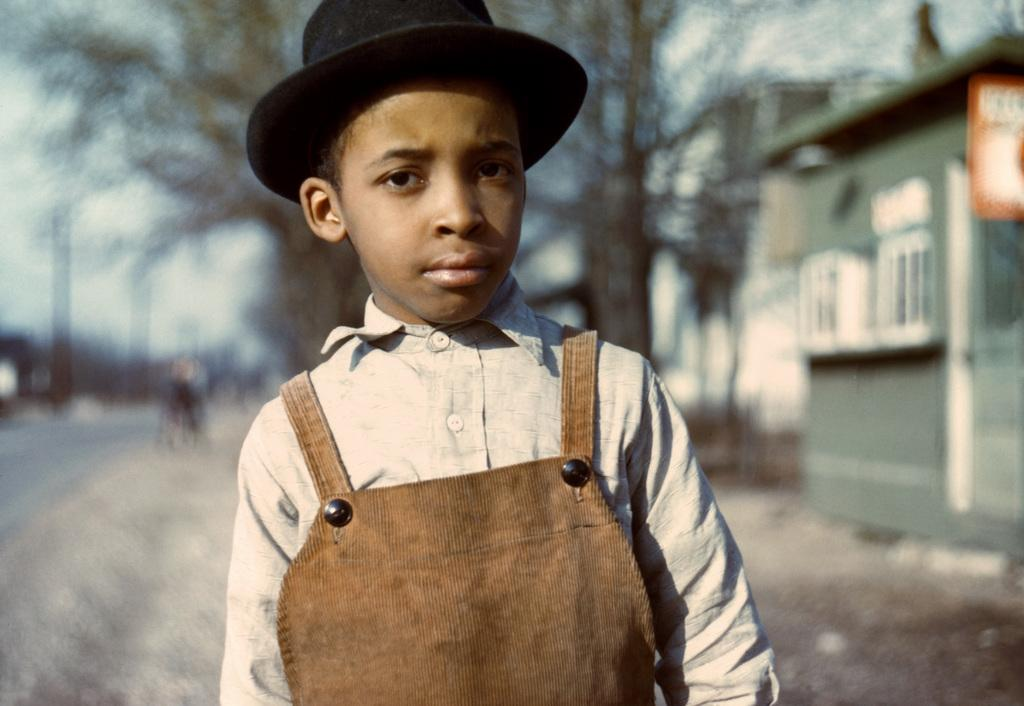What is the main subject of the image? There is a child in the image. What is the child wearing on their head? The child is wearing a cap. What type of vegetation can be seen in the image? There are dried trees in the image. Can you describe the background of the image? The background of the image is blurry. What type of skirt is the child wearing in the image? There is no skirt visible in the image; the child is wearing a cap. How many balloons are floating in the background of the image? There are no balloons present in the image; the background is blurry and features dried trees. 